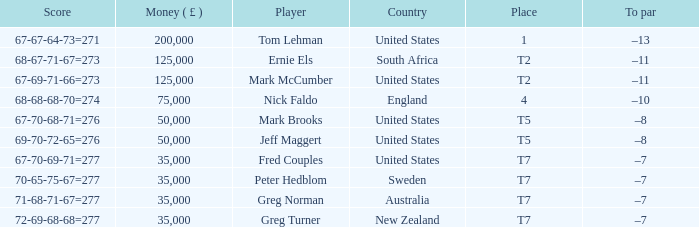What is the score when capital ( £ ) is more than 35,000, and the nation is "united states"? 67-67-64-73=271, 67-69-71-66=273, 67-70-68-71=276, 69-70-72-65=276. Could you parse the entire table as a dict? {'header': ['Score', 'Money ( £ )', 'Player', 'Country', 'Place', 'To par'], 'rows': [['67-67-64-73=271', '200,000', 'Tom Lehman', 'United States', '1', '–13'], ['68-67-71-67=273', '125,000', 'Ernie Els', 'South Africa', 'T2', '–11'], ['67-69-71-66=273', '125,000', 'Mark McCumber', 'United States', 'T2', '–11'], ['68-68-68-70=274', '75,000', 'Nick Faldo', 'England', '4', '–10'], ['67-70-68-71=276', '50,000', 'Mark Brooks', 'United States', 'T5', '–8'], ['69-70-72-65=276', '50,000', 'Jeff Maggert', 'United States', 'T5', '–8'], ['67-70-69-71=277', '35,000', 'Fred Couples', 'United States', 'T7', '–7'], ['70-65-75-67=277', '35,000', 'Peter Hedblom', 'Sweden', 'T7', '–7'], ['71-68-71-67=277', '35,000', 'Greg Norman', 'Australia', 'T7', '–7'], ['72-69-68-68=277', '35,000', 'Greg Turner', 'New Zealand', 'T7', '–7']]} 